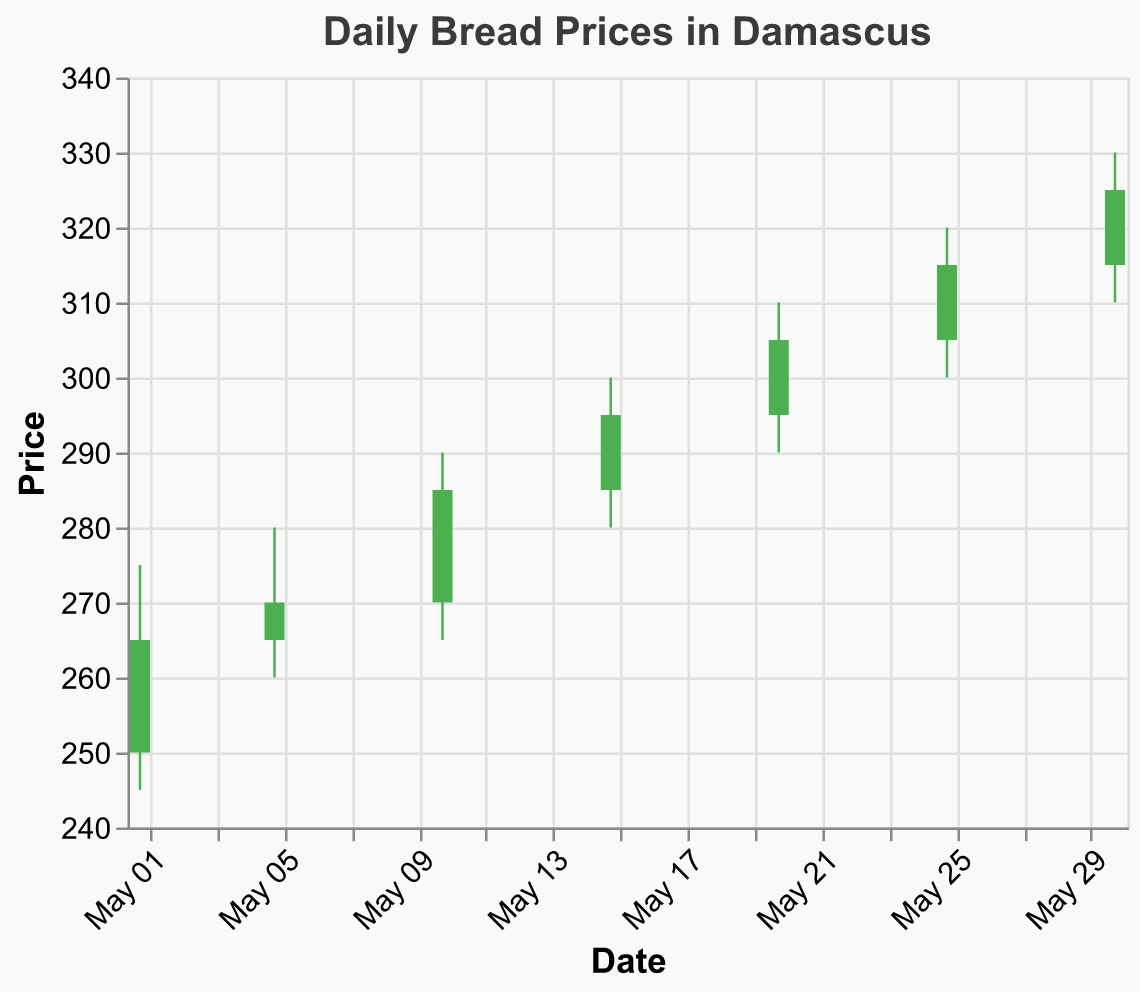What is the title of the chart? The title of the chart is displayed at the top. Therefore, the title of the chart is "Daily Bread Prices in Damascus".
Answer: Daily Bread Prices in Damascus On which date did the closing price surpass 300 for the first time? By examining the "Close" price and corresponding "Date," we see that the first time the closing price surpassed 300 was on May 20th, when the closing price was 305.
Answer: May 20 What is the highest price recorded in the month? To find the highest price recorded, look at the "High" value across all dates. The highest price recorded is 330 on May 30th.
Answer: 330 Compare the price range (High-Low) of May 10 and May 15. Which date has a larger range? Calculate the range for May 10 (290 - 265 = 25) and May 15 (300 - 280 = 20). The larger range is on May 10.
Answer: May 10 What was the opening price on May 1? The opening price on May 1 is provided directly in the chart. The opening price on May 1 is 250.
Answer: 250 Which dates have an increasing trend, where the closing price is higher than the opening price? An increasing trend is identified by comparing the closing price with the opening price: May 1, May 10, May 15, May 20, May 25, and May 30, all show this trend.
Answer: May 1, May 10, May 15, May 20, May 25, May 30 What was the lowest price recorded on May 25? Find the "Low" value for May 25 to see the lowest price recorded. The lowest price on May 25 was 300.
Answer: 300 Calculate the average closing price for the entire month. Add all the closing prices: 265 + 270 + 285 + 295 + 305 + 315 + 325 = 2060, then divide by the number of data points (7). The average is 2060 / 7 = 294.29
Answer: 294.29 